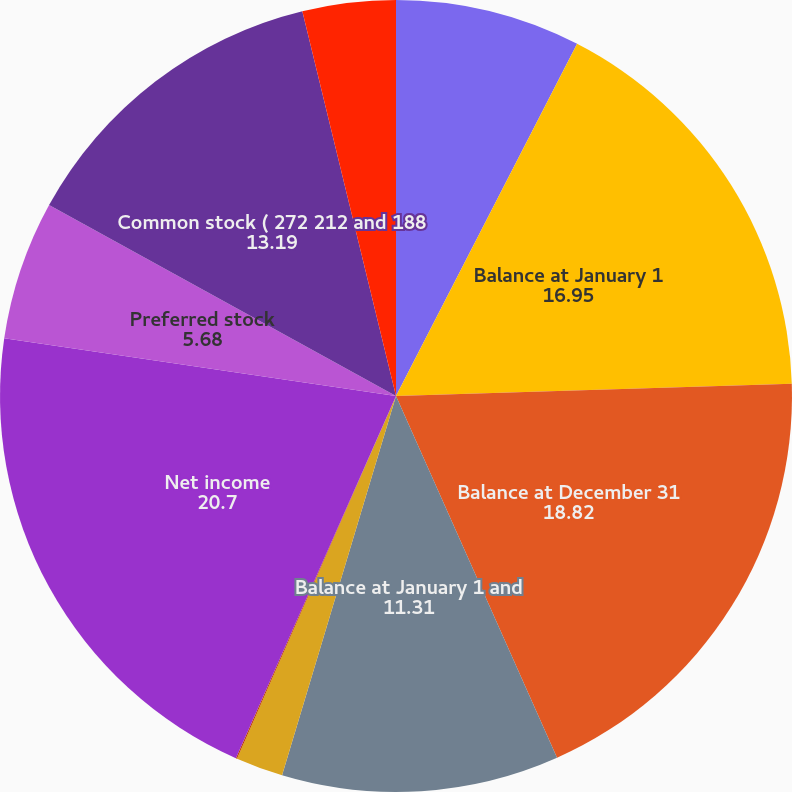<chart> <loc_0><loc_0><loc_500><loc_500><pie_chart><fcel>Year ended December 31 (in<fcel>Balance at January 1<fcel>Balance at December 31<fcel>Balance at January 1 and<fcel>Shares issued and commitments<fcel>Other<fcel>Net income<fcel>Preferred stock<fcel>Common stock ( 272 212 and 188<fcel>Other comprehensive<nl><fcel>7.56%<fcel>16.95%<fcel>18.82%<fcel>11.31%<fcel>1.93%<fcel>0.05%<fcel>20.7%<fcel>5.68%<fcel>13.19%<fcel>3.8%<nl></chart> 